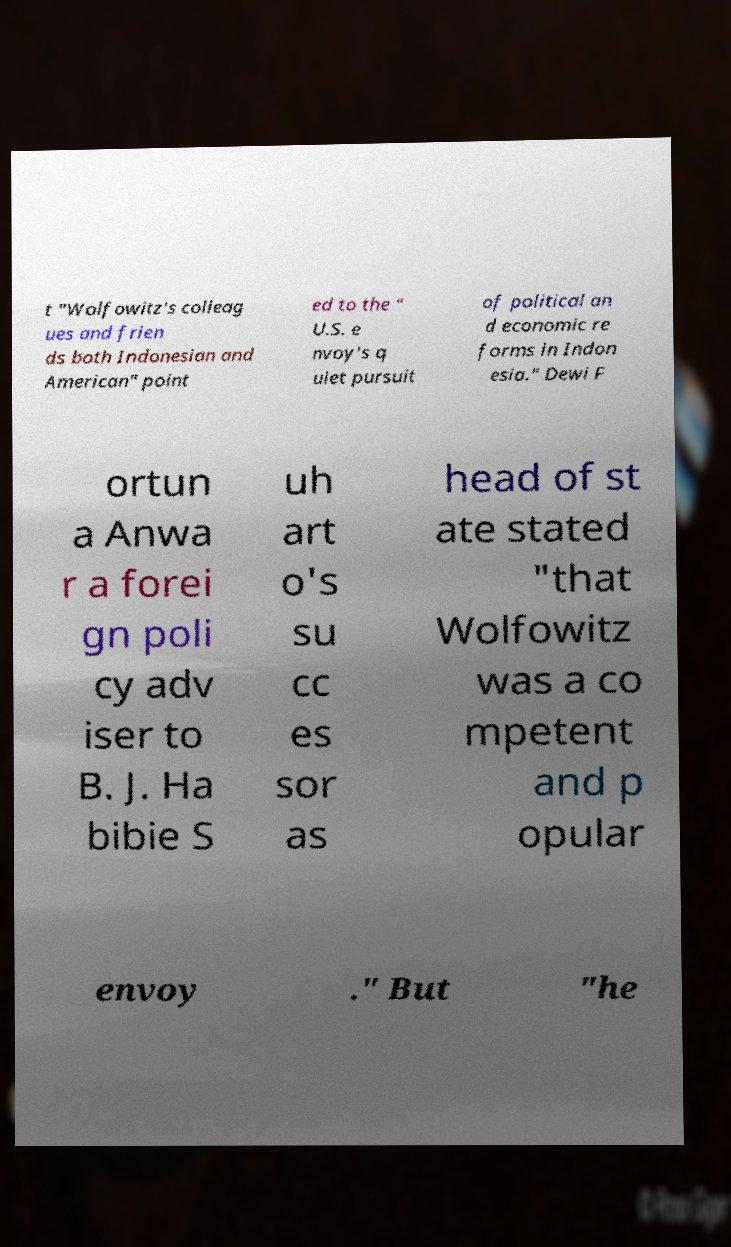Can you read and provide the text displayed in the image?This photo seems to have some interesting text. Can you extract and type it out for me? t "Wolfowitz's colleag ues and frien ds both Indonesian and American" point ed to the " U.S. e nvoy's q uiet pursuit of political an d economic re forms in Indon esia." Dewi F ortun a Anwa r a forei gn poli cy adv iser to B. J. Ha bibie S uh art o's su cc es sor as head of st ate stated "that Wolfowitz was a co mpetent and p opular envoy ." But "he 